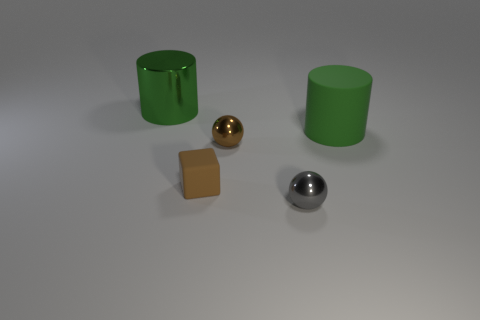Add 3 brown metal objects. How many objects exist? 8 Subtract 2 spheres. How many spheres are left? 0 Subtract all cylinders. How many objects are left? 3 Subtract all green spheres. How many brown cylinders are left? 0 Subtract all brown matte things. Subtract all gray shiny spheres. How many objects are left? 3 Add 4 shiny objects. How many shiny objects are left? 7 Add 1 green metallic things. How many green metallic things exist? 2 Subtract 0 cyan cylinders. How many objects are left? 5 Subtract all brown balls. Subtract all blue cylinders. How many balls are left? 1 